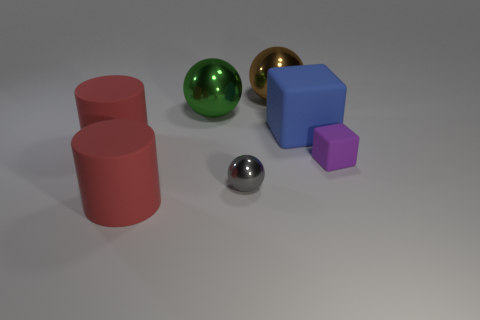There is a gray metallic object; are there any big things to the left of it?
Give a very brief answer. Yes. There is another object that is the same shape as the small purple object; what is it made of?
Your answer should be compact. Rubber. What number of other things are the same shape as the gray thing?
Your answer should be compact. 2. How many gray balls are in front of the blue block that is behind the thing to the right of the large rubber cube?
Provide a short and direct response. 1. What number of other purple rubber things have the same shape as the purple matte object?
Ensure brevity in your answer.  0. The metal object that is in front of the matte cube that is in front of the large cylinder that is behind the small metallic ball is what shape?
Make the answer very short. Sphere. Is the size of the brown metal object the same as the cylinder that is behind the small purple rubber thing?
Give a very brief answer. Yes. Are there any other things of the same size as the blue thing?
Ensure brevity in your answer.  Yes. What number of other things are made of the same material as the blue thing?
Keep it short and to the point. 3. There is a thing that is behind the big blue rubber block and right of the small gray metallic sphere; what color is it?
Keep it short and to the point. Brown. 